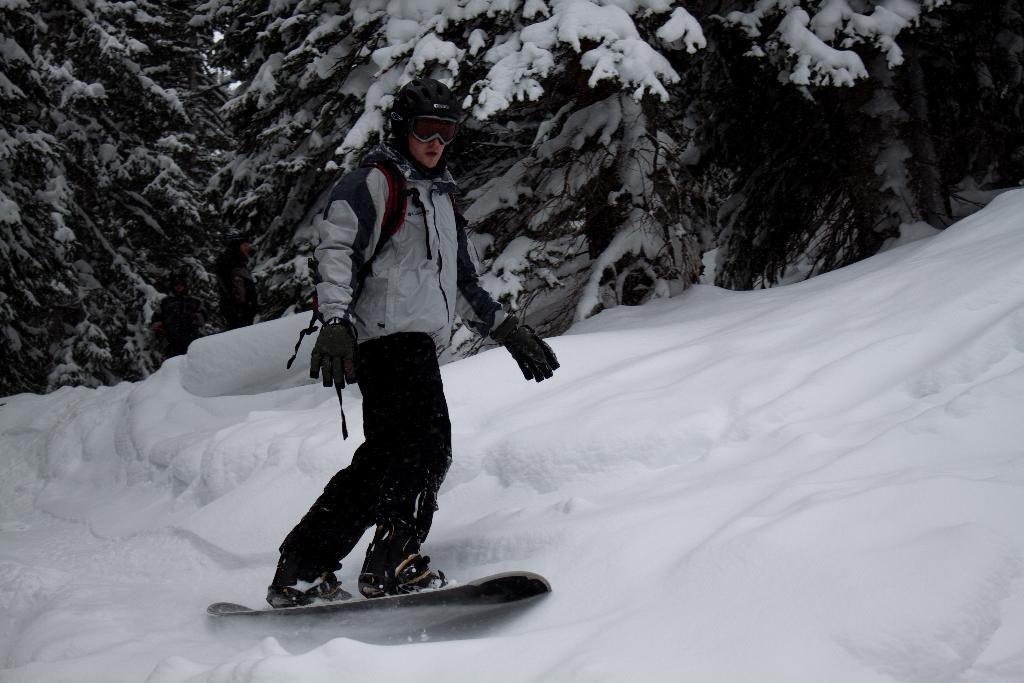What is the person in the image wearing on their head? The person is wearing a helmet in the image. What type of eye protection is the person wearing? The person is wearing goggles in the image. What type of hand protection is the person wearing? The person is wearing gloves in the image. What type of footwear is the person wearing? The person is wearing shoes in the image. What is the person standing on in the image? The person is standing on a snowboard in the image. What can be seen in the background of the image? There is snow and trees in the background of the image. What type of wren can be seen singing in the image? There is no wren present in the image; it features a person wearing protective gear and standing on a snowboard. What type of meal is the person eating while snowboarding in the image? There is no meal present in the image; the person is wearing protective gear and standing on a snowboard. 